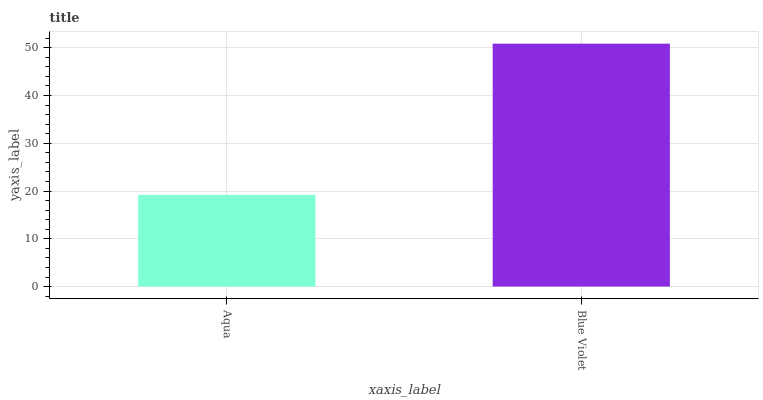Is Aqua the minimum?
Answer yes or no. Yes. Is Blue Violet the maximum?
Answer yes or no. Yes. Is Blue Violet the minimum?
Answer yes or no. No. Is Blue Violet greater than Aqua?
Answer yes or no. Yes. Is Aqua less than Blue Violet?
Answer yes or no. Yes. Is Aqua greater than Blue Violet?
Answer yes or no. No. Is Blue Violet less than Aqua?
Answer yes or no. No. Is Blue Violet the high median?
Answer yes or no. Yes. Is Aqua the low median?
Answer yes or no. Yes. Is Aqua the high median?
Answer yes or no. No. Is Blue Violet the low median?
Answer yes or no. No. 